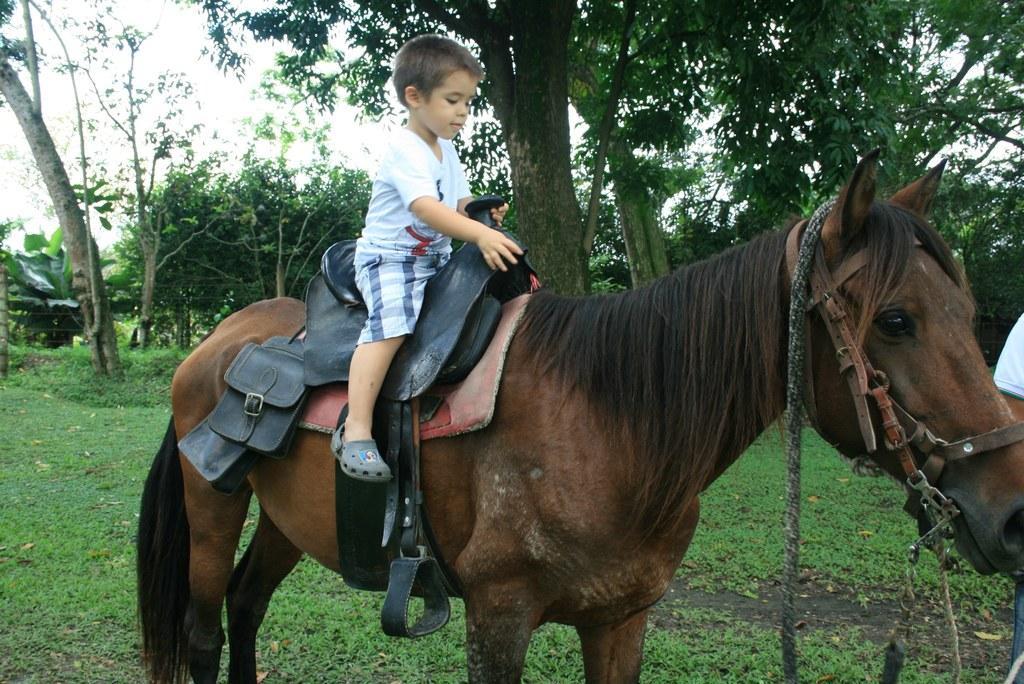Could you give a brief overview of what you see in this image? In this image there is a kid sitting on the horse and at the background of the image there are trees. 